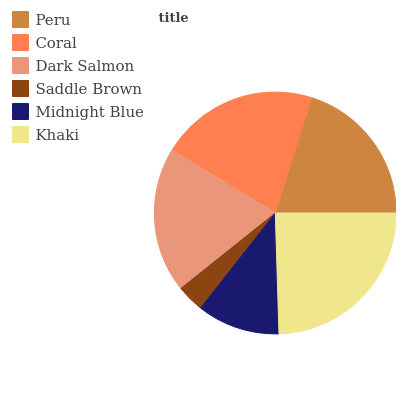Is Saddle Brown the minimum?
Answer yes or no. Yes. Is Khaki the maximum?
Answer yes or no. Yes. Is Coral the minimum?
Answer yes or no. No. Is Coral the maximum?
Answer yes or no. No. Is Coral greater than Peru?
Answer yes or no. Yes. Is Peru less than Coral?
Answer yes or no. Yes. Is Peru greater than Coral?
Answer yes or no. No. Is Coral less than Peru?
Answer yes or no. No. Is Peru the high median?
Answer yes or no. Yes. Is Dark Salmon the low median?
Answer yes or no. Yes. Is Khaki the high median?
Answer yes or no. No. Is Midnight Blue the low median?
Answer yes or no. No. 